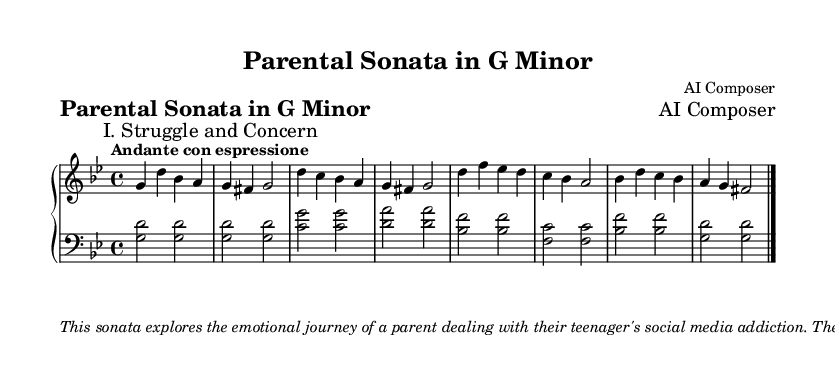What is the key signature of this music? The key signature is indicated at the beginning of the score and consists of two flats, which corresponds to G minor.
Answer: G minor What is the time signature of the piece? The time signature shown in the score is located at the beginning and is represented by the fraction 4/4, indicating four beats per measure.
Answer: 4/4 What is the tempo marking for this sonata? The tempo marking appears at the beginning and is "Andante con espressione," indicating a moderately slow tempo with expressive nuances.
Answer: Andante con espressione How many main themes are there in this sonata? The score is divided into two sections with distinct labels: "I. Struggle and Concern" covers the main theme, while hints of a secondary theme follow. Thus, there are two main themes.
Answer: Two What does the shift from G minor to B flat signify in the piece? The transition to the relative major key (B flat) suggests moments of hope and connection amidst the struggle described in the piece, reflecting emotional growth.
Answer: Hope and connection What is the performance suggestion in the markup? The markup includes a direction to perform the piece with sensitivity and to use rubato, which is a technique that allows for expressive timing modifications, especially on poignant moments.
Answer: Sensitivity and rubato 